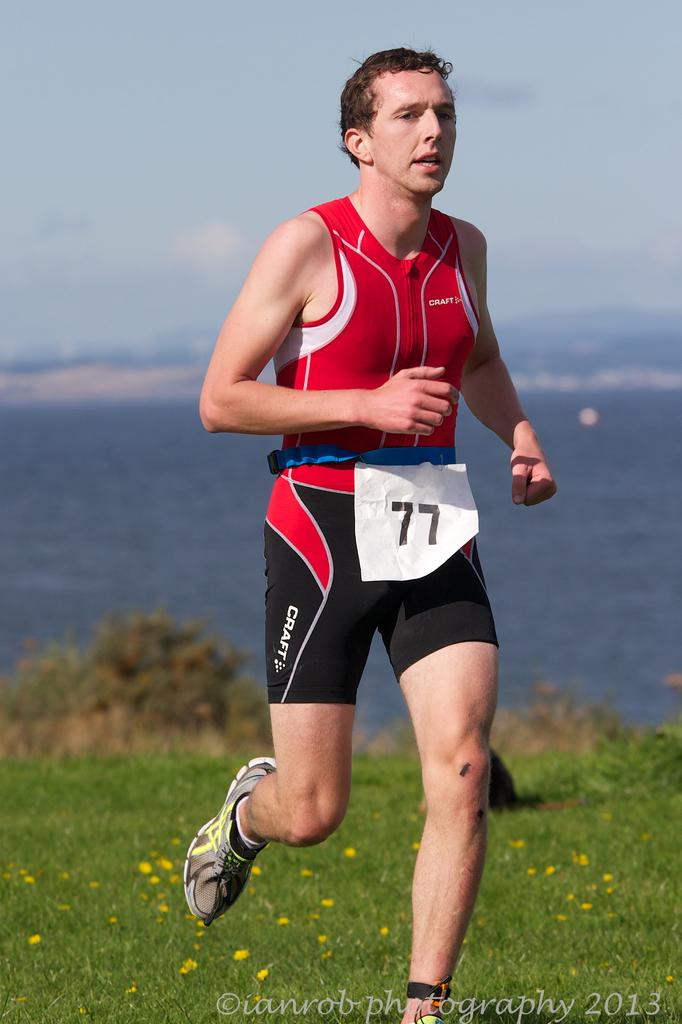<image>
Create a compact narrative representing the image presented. Runner number 77 running a cross country race. 